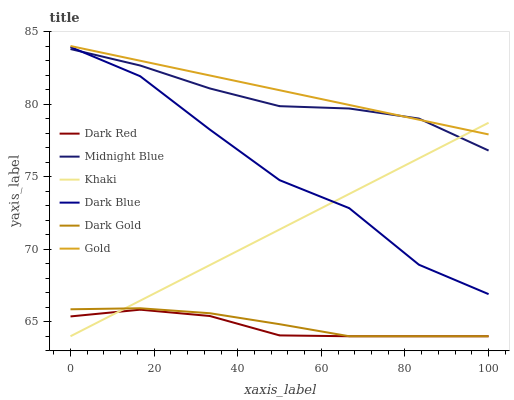Does Dark Red have the minimum area under the curve?
Answer yes or no. Yes. Does Gold have the maximum area under the curve?
Answer yes or no. Yes. Does Midnight Blue have the minimum area under the curve?
Answer yes or no. No. Does Midnight Blue have the maximum area under the curve?
Answer yes or no. No. Is Gold the smoothest?
Answer yes or no. Yes. Is Dark Blue the roughest?
Answer yes or no. Yes. Is Midnight Blue the smoothest?
Answer yes or no. No. Is Midnight Blue the roughest?
Answer yes or no. No. Does Midnight Blue have the lowest value?
Answer yes or no. No. Does Gold have the highest value?
Answer yes or no. Yes. Does Midnight Blue have the highest value?
Answer yes or no. No. Is Dark Red less than Dark Blue?
Answer yes or no. Yes. Is Gold greater than Dark Gold?
Answer yes or no. Yes. Does Dark Red intersect Dark Blue?
Answer yes or no. No. 